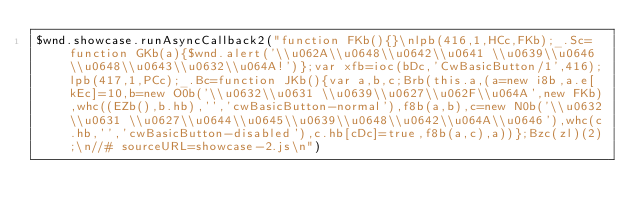Convert code to text. <code><loc_0><loc_0><loc_500><loc_500><_JavaScript_>$wnd.showcase.runAsyncCallback2("function FKb(){}\nlpb(416,1,HCc,FKb);_.Sc=function GKb(a){$wnd.alert('\\u062A\\u0648\\u0642\\u0641 \\u0639\\u0646 \\u0648\\u0643\\u0632\\u064A!')};var xfb=ioc(bDc,'CwBasicButton/1',416);lpb(417,1,PCc);_.Bc=function JKb(){var a,b,c;Brb(this.a,(a=new i8b,a.e[kEc]=10,b=new O0b('\\u0632\\u0631 \\u0639\\u0627\\u062F\\u064A',new FKb),whc((EZb(),b.hb),'','cwBasicButton-normal'),f8b(a,b),c=new N0b('\\u0632\\u0631 \\u0627\\u0644\\u0645\\u0639\\u0648\\u0642\\u064A\\u0646'),whc(c.hb,'','cwBasicButton-disabled'),c.hb[cDc]=true,f8b(a,c),a))};Bzc(zl)(2);\n//# sourceURL=showcase-2.js\n")
</code> 